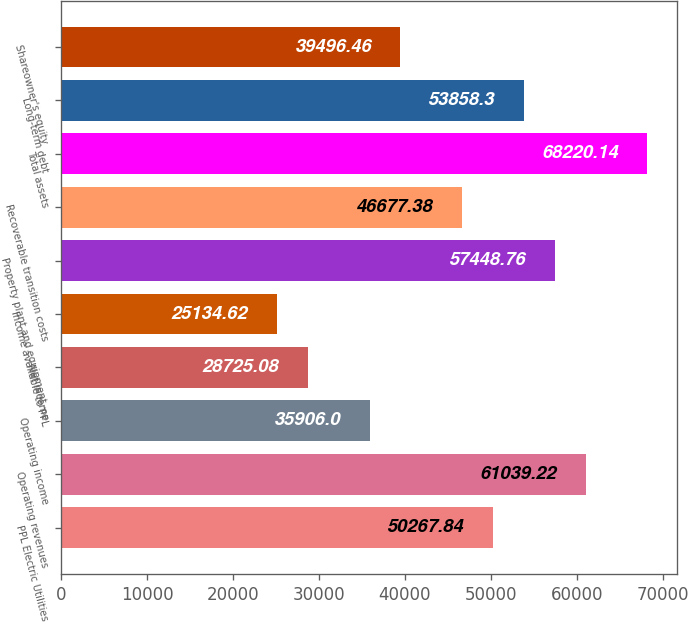Convert chart. <chart><loc_0><loc_0><loc_500><loc_500><bar_chart><fcel>PPL Electric Utilities<fcel>Operating revenues<fcel>Operating income<fcel>Net income<fcel>Income available to PPL<fcel>Property plant and equipment -<fcel>Recoverable transition costs<fcel>Total assets<fcel>Long-term debt<fcel>Shareowner's equity<nl><fcel>50267.8<fcel>61039.2<fcel>35906<fcel>28725.1<fcel>25134.6<fcel>57448.8<fcel>46677.4<fcel>68220.1<fcel>53858.3<fcel>39496.5<nl></chart> 